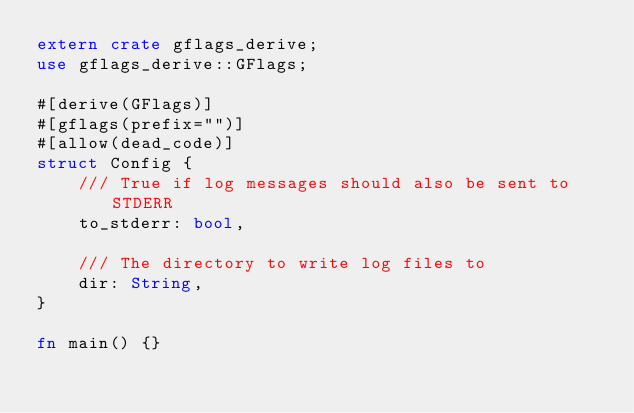Convert code to text. <code><loc_0><loc_0><loc_500><loc_500><_Rust_>extern crate gflags_derive;
use gflags_derive::GFlags;

#[derive(GFlags)]
#[gflags(prefix="")]
#[allow(dead_code)]
struct Config {
    /// True if log messages should also be sent to STDERR
    to_stderr: bool,

    /// The directory to write log files to
    dir: String,
}

fn main() {}</code> 